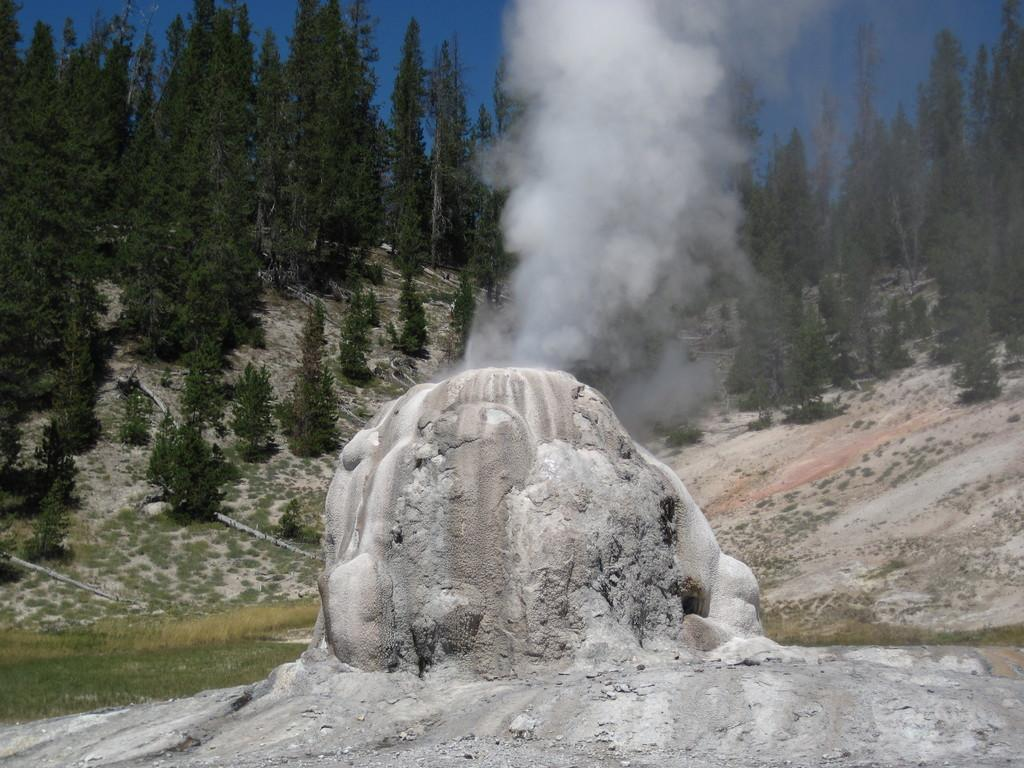What type of natural landform can be seen in the image? There are mountains in the image. What is the source of the smoke visible in the image? The source of the smoke is not specified in the image. What type of vegetation is present in the image? There is grass and trees in the image. What part of the natural environment is visible in the image? The sky is visible in the image. Can you determine the time of day when the image was taken? Yes, the image was taken during the day. What type of comb is used to style the trees in the image? There is no comb present in the image, and the trees are not styled. How does the government influence the appearance of the mountains in the image? The image does not show any government influence on the appearance of the mountains. 